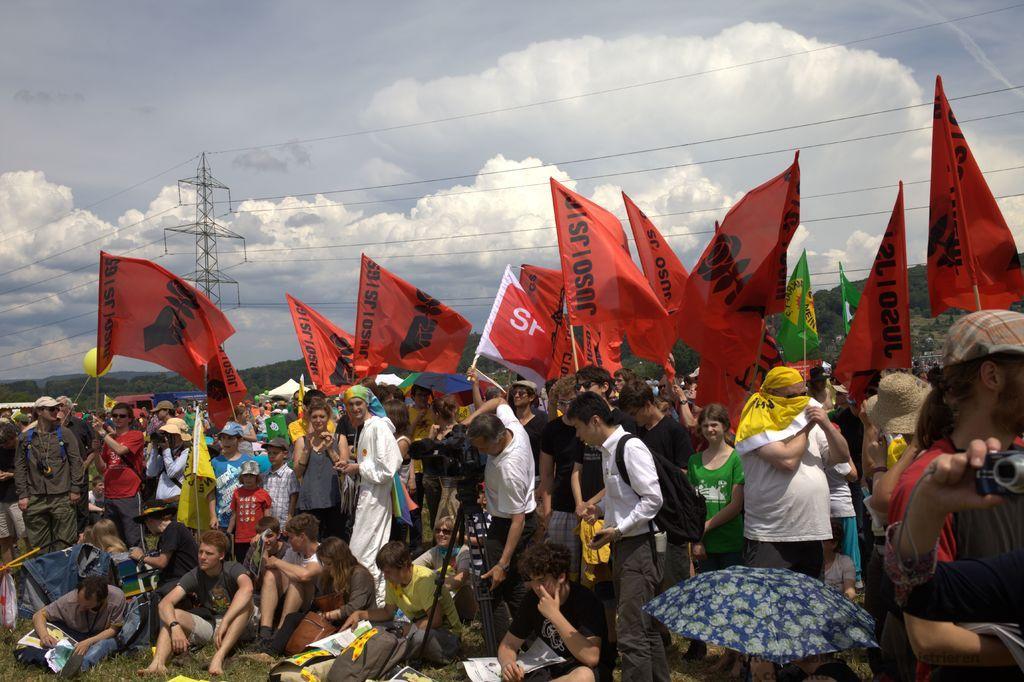In one or two sentences, can you explain what this image depicts? In the center of the image we can see people standing and some of them are sitting. There are flags. In the background there are wires, tower, hills and sky. There is an umbrella. 